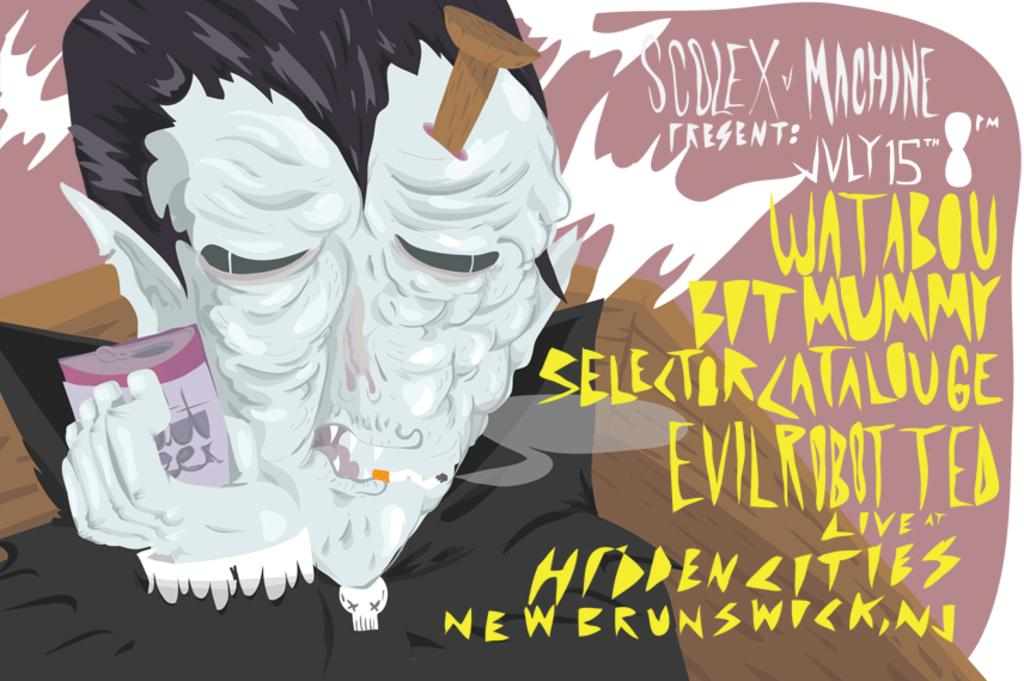What is on the left side of the picture? There is a cartoon image on the left side of the picture. What is the cartoon doing in the image? The cartoon is holding an object in the image. What can be found on the right side of the picture? There is text and other objects on the right side of the picture. Are there any numerical values visible in the image? Yes, there are numbers visible in the image. What is the rate of the thrill experienced by the cartoon in the image? There is no information about the rate or thrill experienced by the cartoon in the image. How does the cartoon adjust its position in the image? The cartoon is a static image and does not adjust its position in the image. 